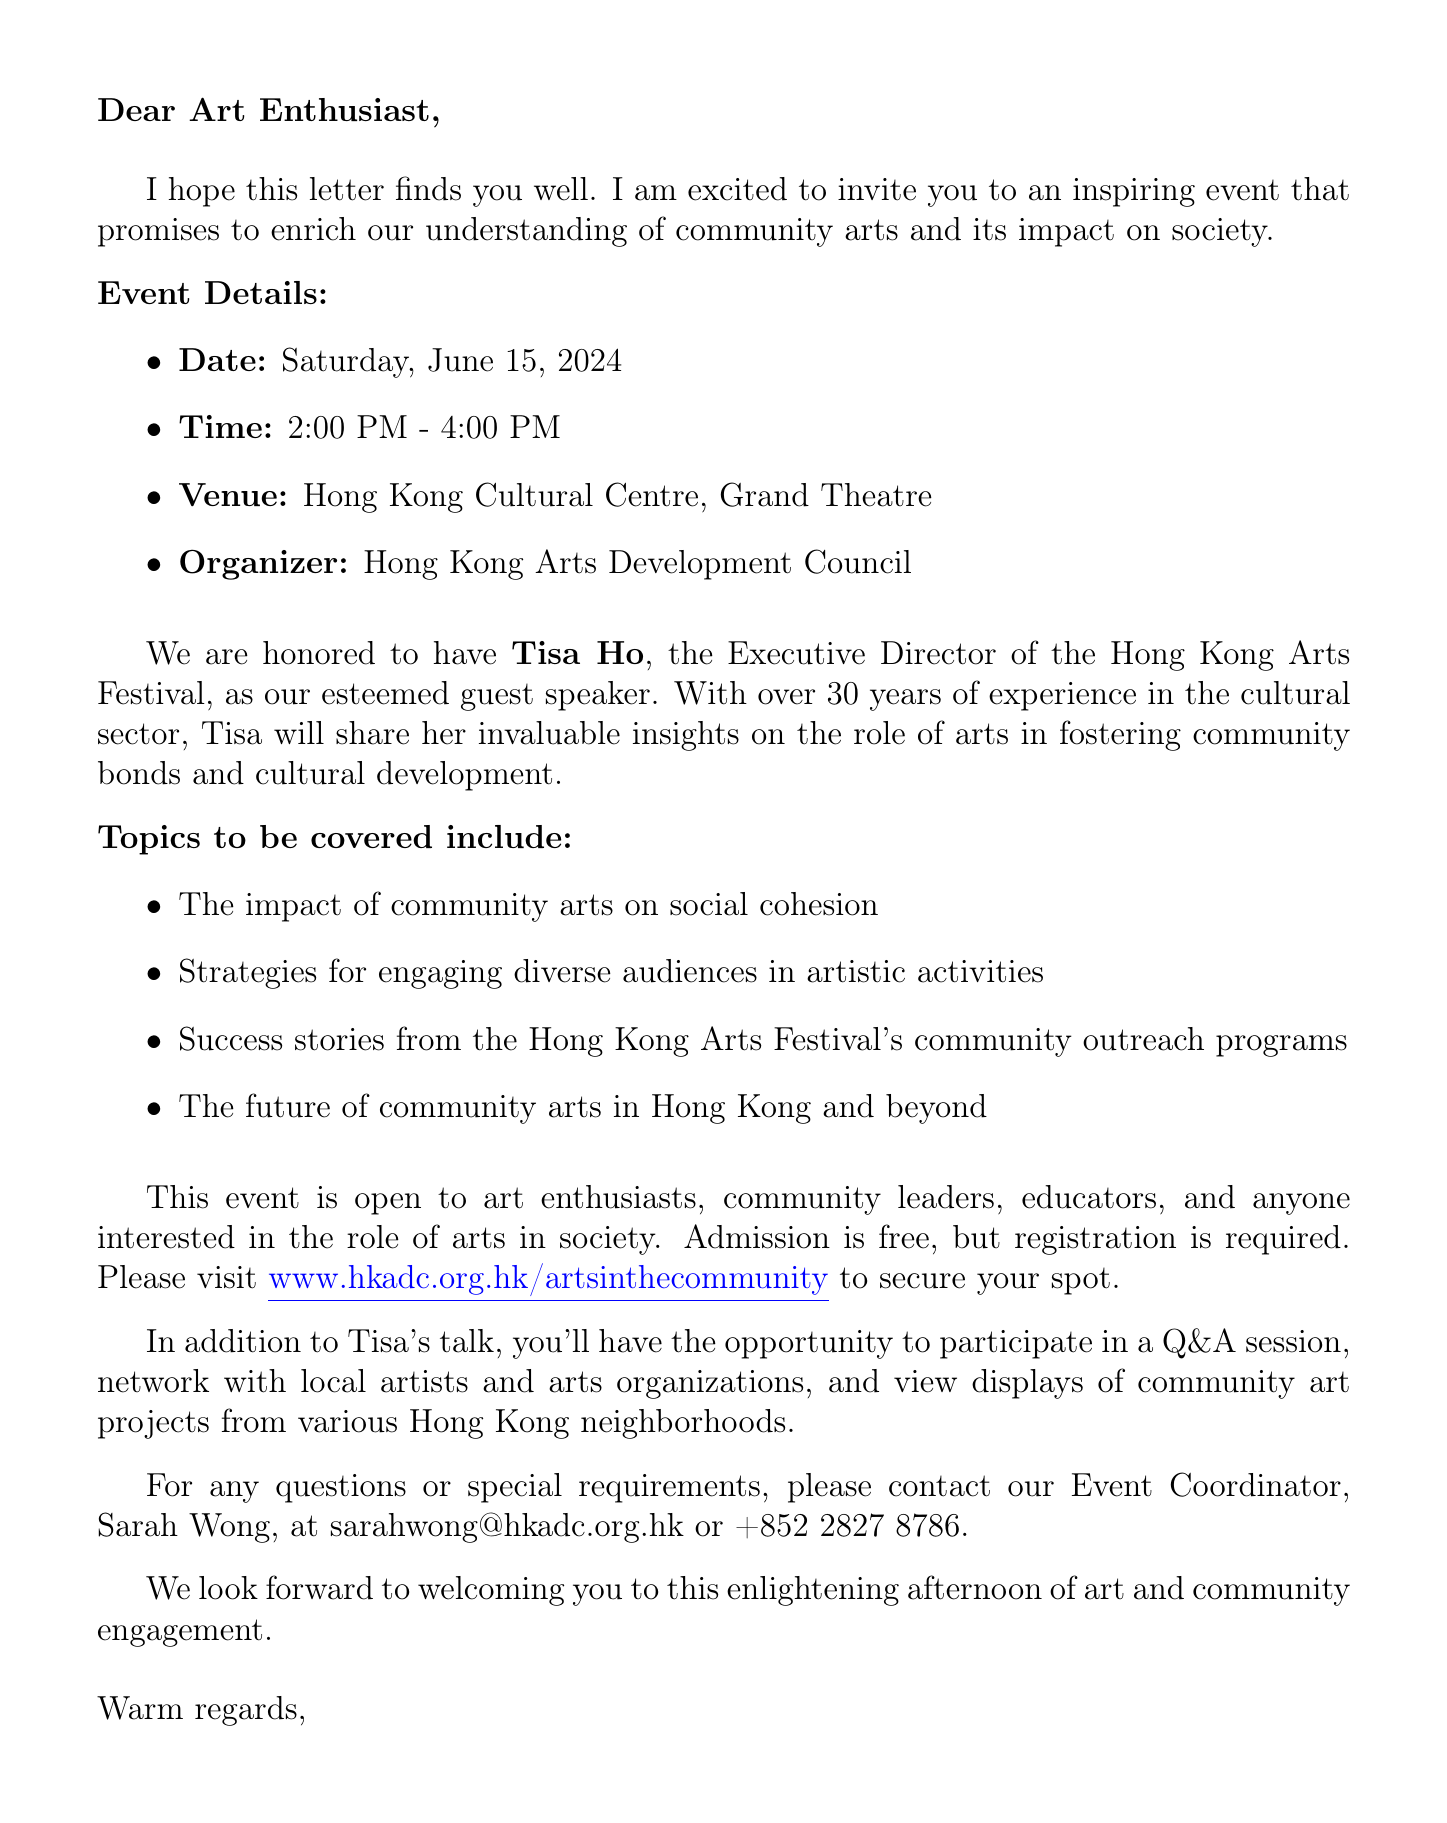what is the event name? The event name is listed at the beginning of the document.
Answer: Art in the Community: A Dialogue with Tisa Ho when will the event take place? The date of the event is specified in the document.
Answer: Saturday, June 15, 2024 who is the guest speaker? The name and title of the guest speaker are provided in the document.
Answer: Tisa Ho what is the admission fee? The admission details can be found in the document's event description.
Answer: Free (Registration required) what topics will be covered? Specific topics to be covered are listed in a bullet format in the document.
Answer: The impact of community arts on social cohesion who is the organizer of the event? The organizer's name is mentioned in the event details section.
Answer: Hong Kong Arts Development Council how long will the event last? The duration is mentioned alongside the time in the event details.
Answer: 2 hours what types of additional activities will be available? The document lists various additional activities included in the event.
Answer: Q&A session with Tisa Ho how can participants contact for more information? The contact person's details are given towards the end of the document.
Answer: sarahwong@hkadc.org.hk 